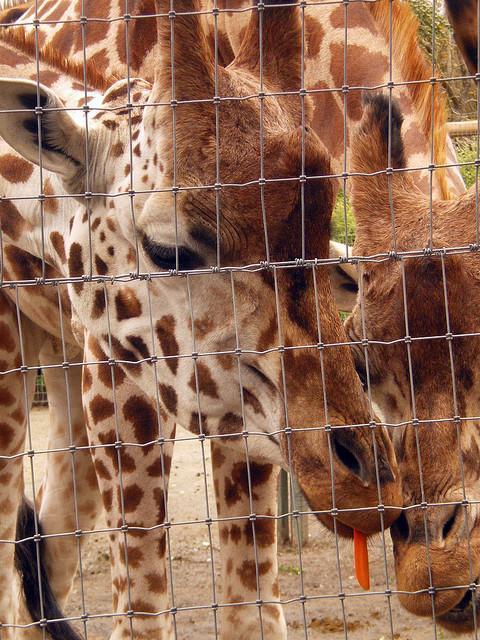How many giraffes are in this photo?
Give a very brief answer. 2. How many giraffes can you see?
Give a very brief answer. 2. 